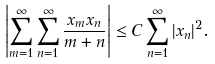<formula> <loc_0><loc_0><loc_500><loc_500>\left | \sum _ { m = 1 } ^ { \infty } \sum _ { n = 1 } ^ { \infty } \frac { x _ { m } x _ { n } } { m + n } \right | \leq C \sum _ { n = 1 } ^ { \infty } | x _ { n } | ^ { 2 } .</formula> 